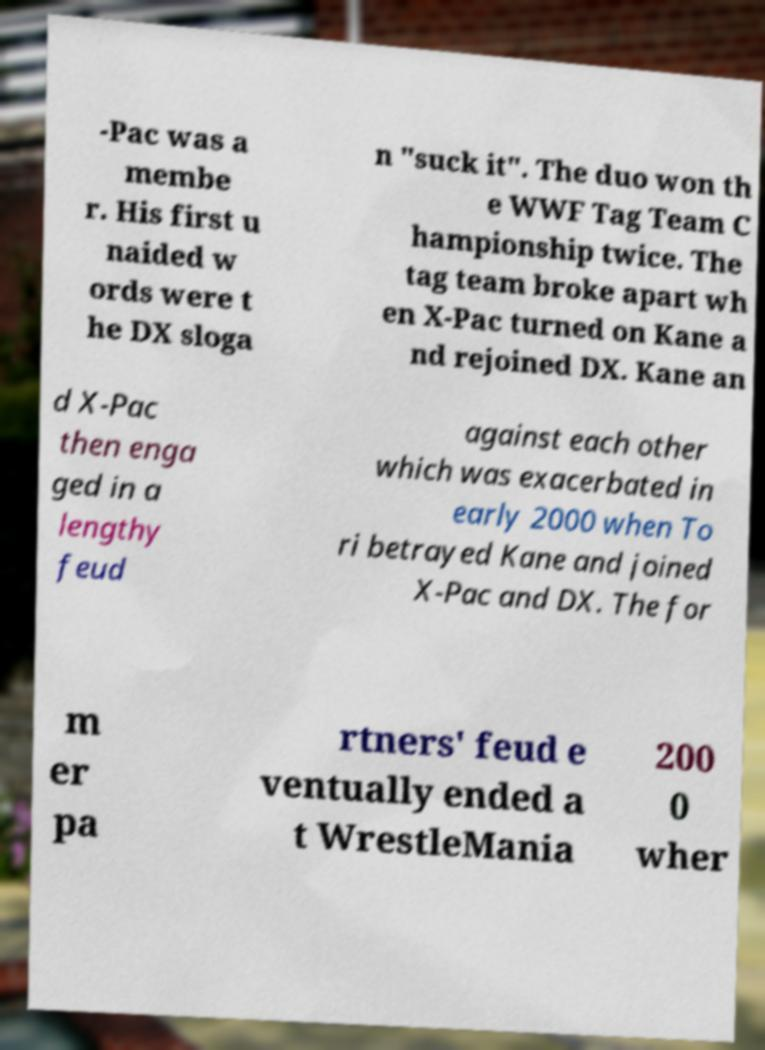Please identify and transcribe the text found in this image. -Pac was a membe r. His first u naided w ords were t he DX sloga n "suck it". The duo won th e WWF Tag Team C hampionship twice. The tag team broke apart wh en X-Pac turned on Kane a nd rejoined DX. Kane an d X-Pac then enga ged in a lengthy feud against each other which was exacerbated in early 2000 when To ri betrayed Kane and joined X-Pac and DX. The for m er pa rtners' feud e ventually ended a t WrestleMania 200 0 wher 